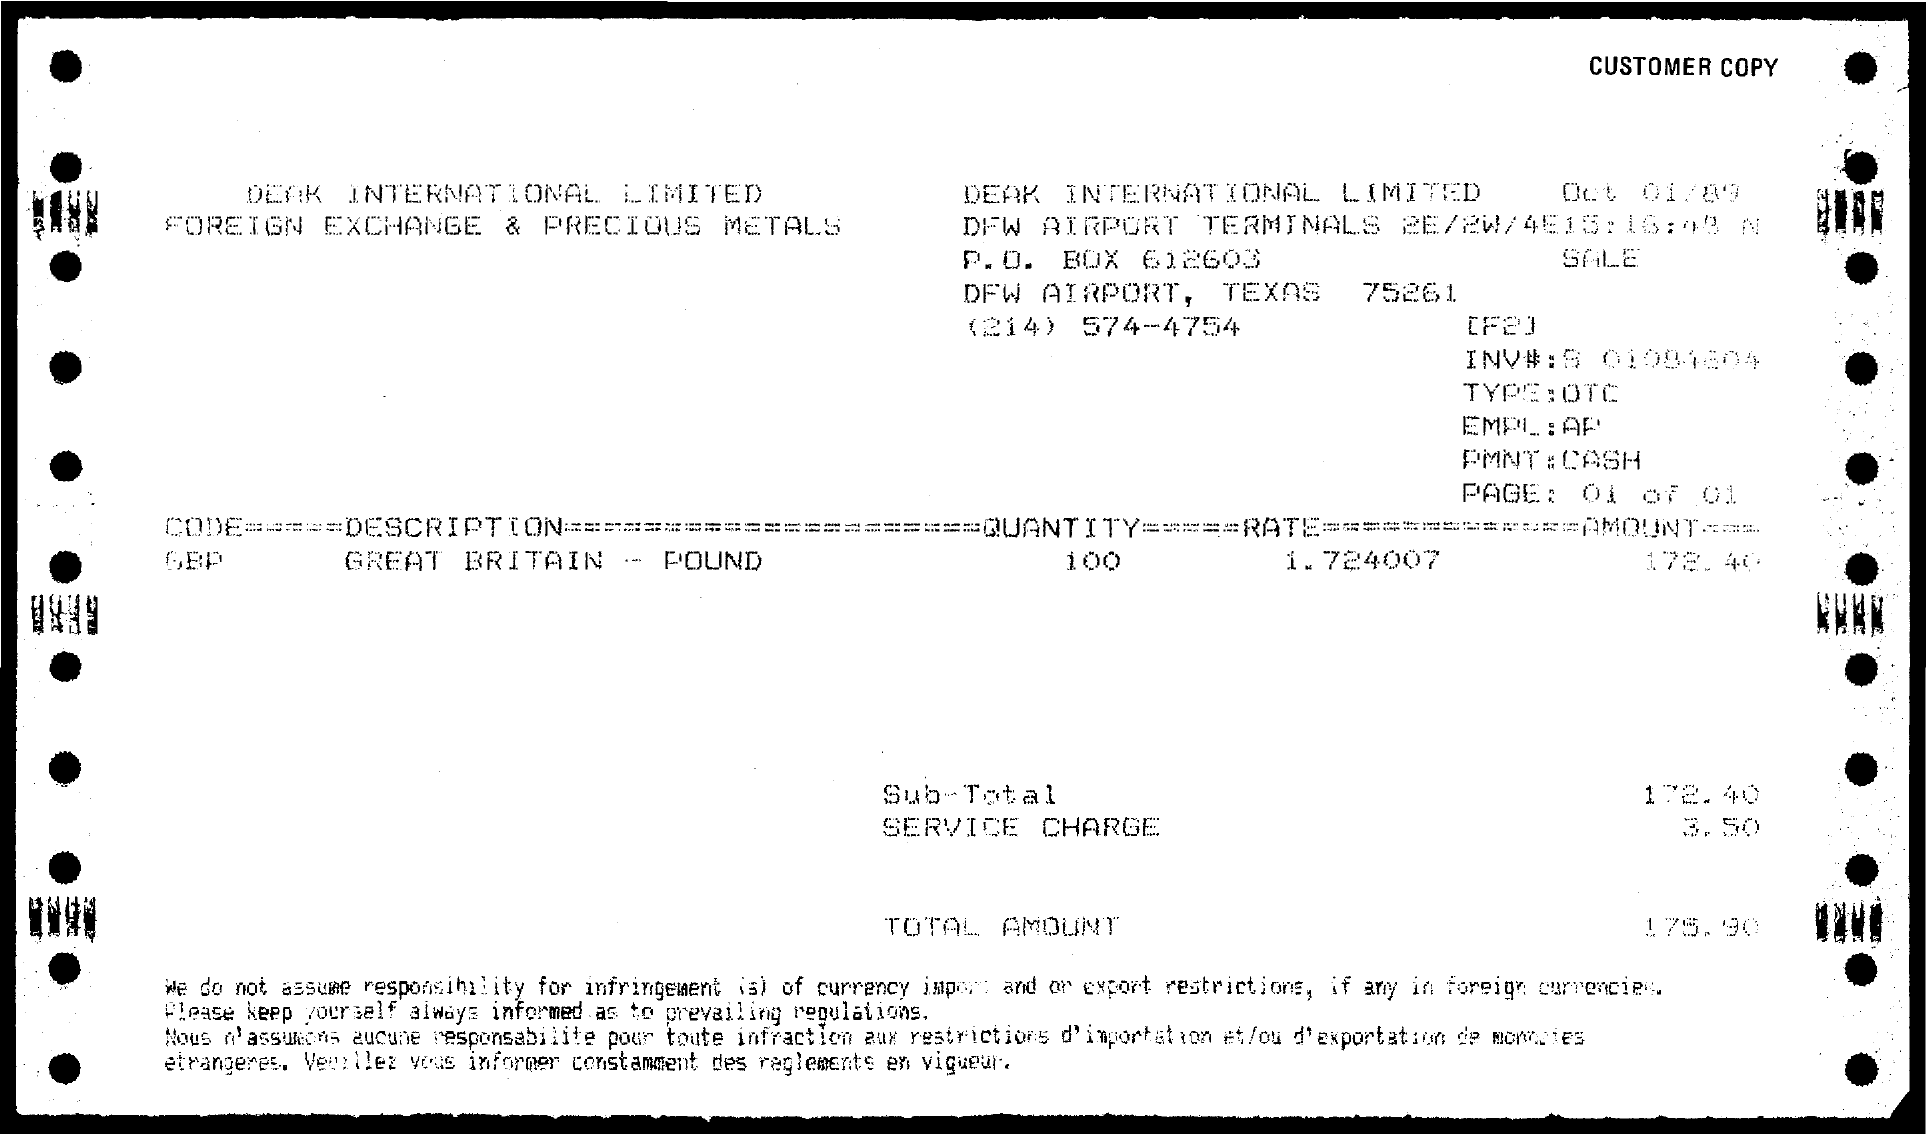Identify some key points in this picture. The sub-total is 172.40 dollars. The rate is 1.724007... What is the PMNT:? CASH. The description refers to Great Britain and its currency, which is the pound. What is the Quantity? It is 100.. 